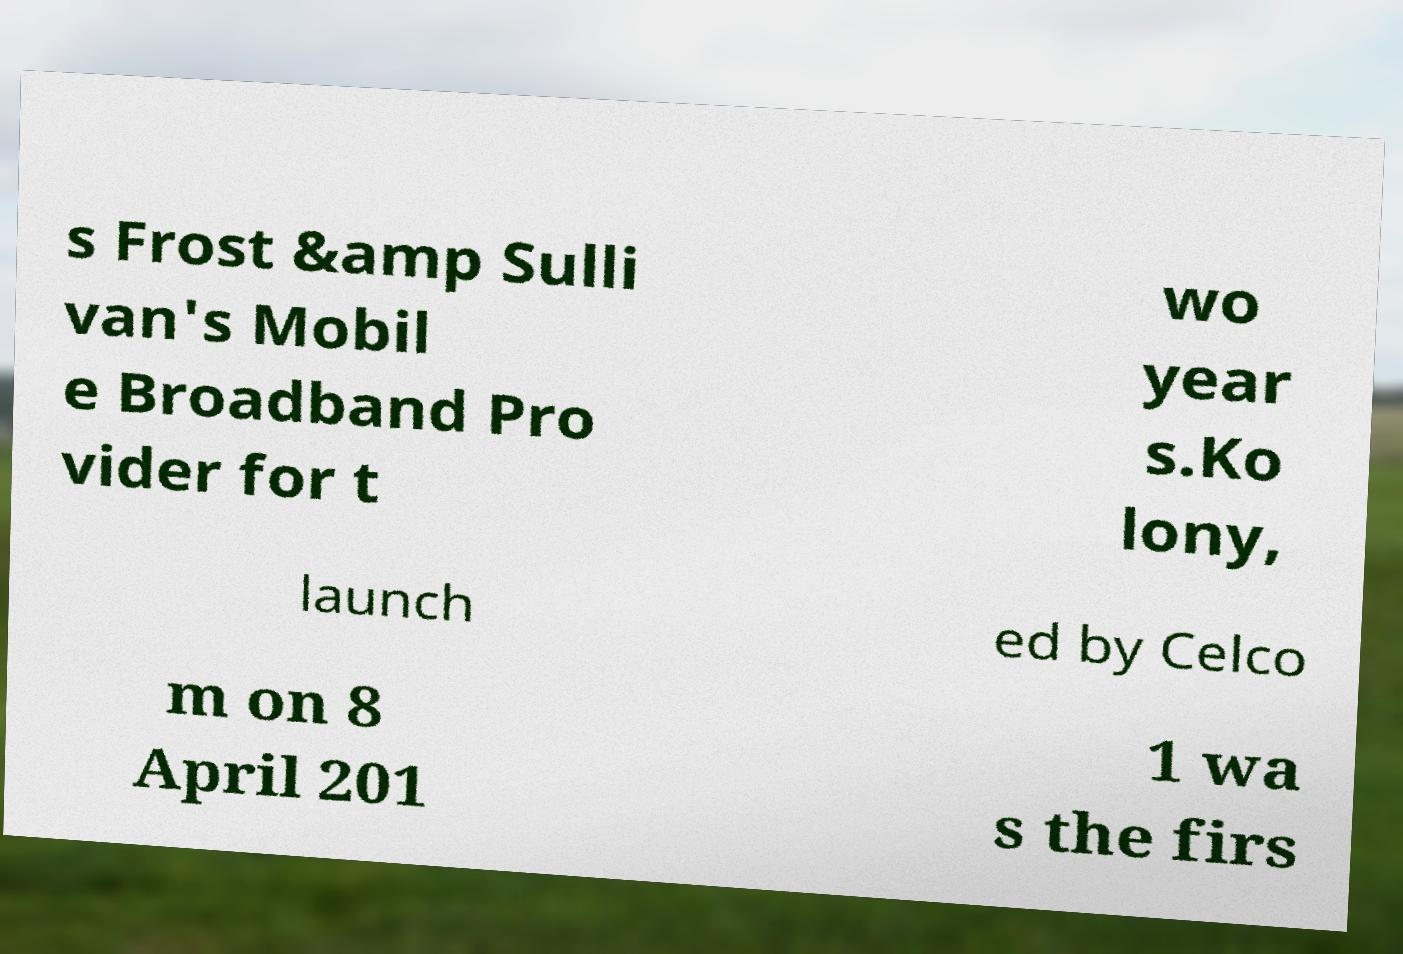Can you accurately transcribe the text from the provided image for me? s Frost &amp Sulli van's Mobil e Broadband Pro vider for t wo year s.Ko lony, launch ed by Celco m on 8 April 201 1 wa s the firs 